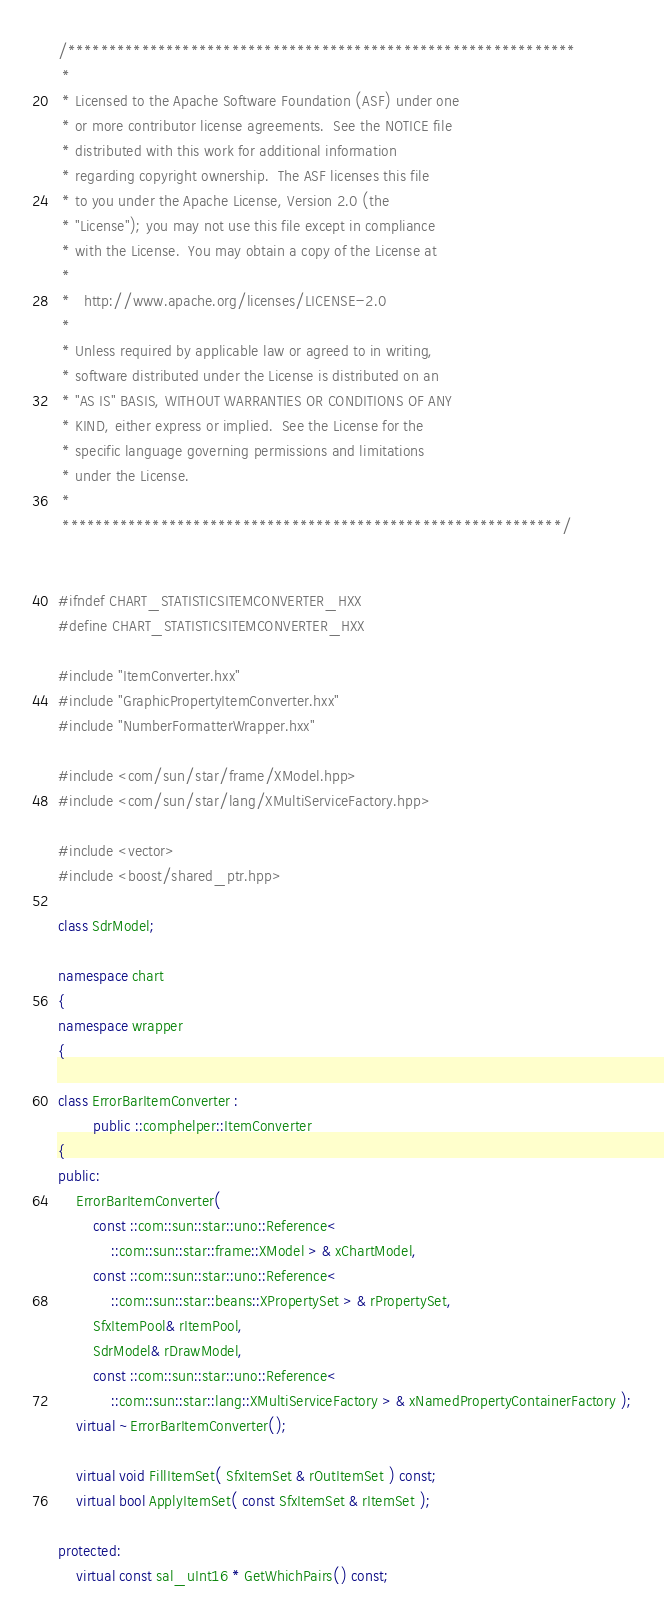<code> <loc_0><loc_0><loc_500><loc_500><_C++_>/**************************************************************
 * 
 * Licensed to the Apache Software Foundation (ASF) under one
 * or more contributor license agreements.  See the NOTICE file
 * distributed with this work for additional information
 * regarding copyright ownership.  The ASF licenses this file
 * to you under the Apache License, Version 2.0 (the
 * "License"); you may not use this file except in compliance
 * with the License.  You may obtain a copy of the License at
 * 
 *   http://www.apache.org/licenses/LICENSE-2.0
 * 
 * Unless required by applicable law or agreed to in writing,
 * software distributed under the License is distributed on an
 * "AS IS" BASIS, WITHOUT WARRANTIES OR CONDITIONS OF ANY
 * KIND, either express or implied.  See the License for the
 * specific language governing permissions and limitations
 * under the License.
 * 
 *************************************************************/


#ifndef CHART_STATISTICSITEMCONVERTER_HXX
#define CHART_STATISTICSITEMCONVERTER_HXX

#include "ItemConverter.hxx"
#include "GraphicPropertyItemConverter.hxx"
#include "NumberFormatterWrapper.hxx"

#include <com/sun/star/frame/XModel.hpp>
#include <com/sun/star/lang/XMultiServiceFactory.hpp>

#include <vector>
#include <boost/shared_ptr.hpp>

class SdrModel;

namespace chart
{
namespace wrapper
{

class ErrorBarItemConverter :
        public ::comphelper::ItemConverter
{
public:
    ErrorBarItemConverter(
        const ::com::sun::star::uno::Reference<
            ::com::sun::star::frame::XModel > & xChartModel,
        const ::com::sun::star::uno::Reference<
            ::com::sun::star::beans::XPropertySet > & rPropertySet,
        SfxItemPool& rItemPool,
        SdrModel& rDrawModel,
        const ::com::sun::star::uno::Reference<
            ::com::sun::star::lang::XMultiServiceFactory > & xNamedPropertyContainerFactory );
    virtual ~ErrorBarItemConverter();

    virtual void FillItemSet( SfxItemSet & rOutItemSet ) const;
    virtual bool ApplyItemSet( const SfxItemSet & rItemSet );

protected:
    virtual const sal_uInt16 * GetWhichPairs() const;</code> 